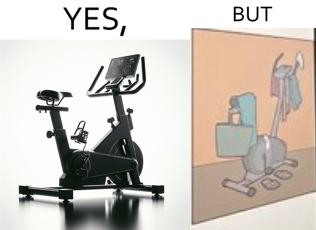Describe the content of this image. This is a satirical image with contrasting elements. 